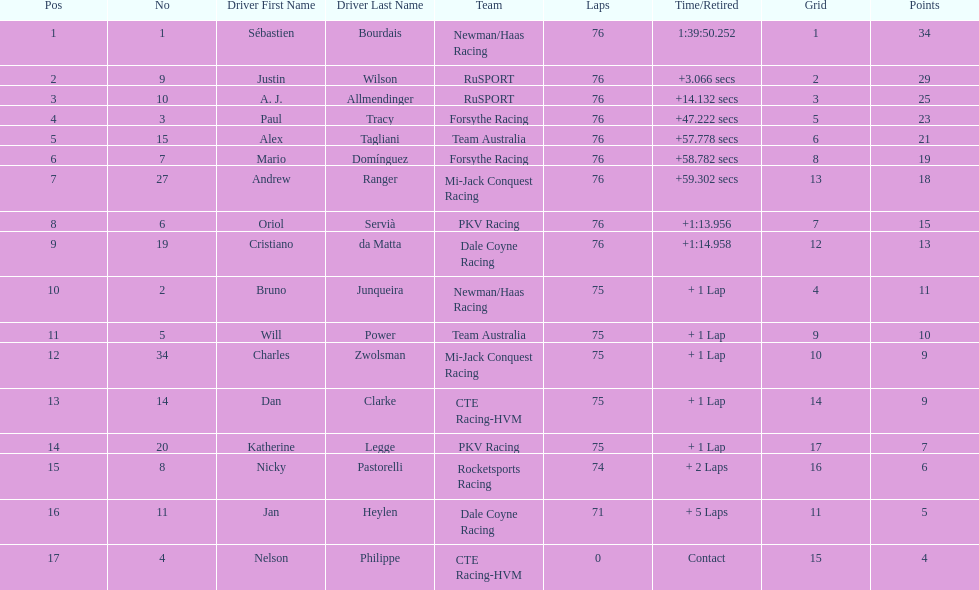I'm looking to parse the entire table for insights. Could you assist me with that? {'header': ['Pos', 'No', 'Driver First Name', 'Driver Last Name', 'Team', 'Laps', 'Time/Retired', 'Grid', 'Points'], 'rows': [['1', '1', 'Sébastien', 'Bourdais', 'Newman/Haas Racing', '76', '1:39:50.252', '1', '34'], ['2', '9', 'Justin', 'Wilson', 'RuSPORT', '76', '+3.066 secs', '2', '29'], ['3', '10', 'A. J.', 'Allmendinger', 'RuSPORT', '76', '+14.132 secs', '3', '25'], ['4', '3', 'Paul', 'Tracy', 'Forsythe Racing', '76', '+47.222 secs', '5', '23'], ['5', '15', 'Alex', 'Tagliani', 'Team Australia', '76', '+57.778 secs', '6', '21'], ['6', '7', 'Mario', 'Domínguez', 'Forsythe Racing', '76', '+58.782 secs', '8', '19'], ['7', '27', 'Andrew', 'Ranger', 'Mi-Jack Conquest Racing', '76', '+59.302 secs', '13', '18'], ['8', '6', 'Oriol', 'Servià', 'PKV Racing', '76', '+1:13.956', '7', '15'], ['9', '19', 'Cristiano', 'da Matta', 'Dale Coyne Racing', '76', '+1:14.958', '12', '13'], ['10', '2', 'Bruno', 'Junqueira', 'Newman/Haas Racing', '75', '+ 1 Lap', '4', '11'], ['11', '5', 'Will', 'Power', 'Team Australia', '75', '+ 1 Lap', '9', '10'], ['12', '34', 'Charles', 'Zwolsman', 'Mi-Jack Conquest Racing', '75', '+ 1 Lap', '10', '9'], ['13', '14', 'Dan', 'Clarke', 'CTE Racing-HVM', '75', '+ 1 Lap', '14', '9'], ['14', '20', 'Katherine', 'Legge', 'PKV Racing', '75', '+ 1 Lap', '17', '7'], ['15', '8', 'Nicky', 'Pastorelli', 'Rocketsports Racing', '74', '+ 2 Laps', '16', '6'], ['16', '11', 'Jan', 'Heylen', 'Dale Coyne Racing', '71', '+ 5 Laps', '11', '5'], ['17', '4', 'Nelson', 'Philippe', 'CTE Racing-HVM', '0', 'Contact', '15', '4']]} How many drivers were competing for brazil? 2. 